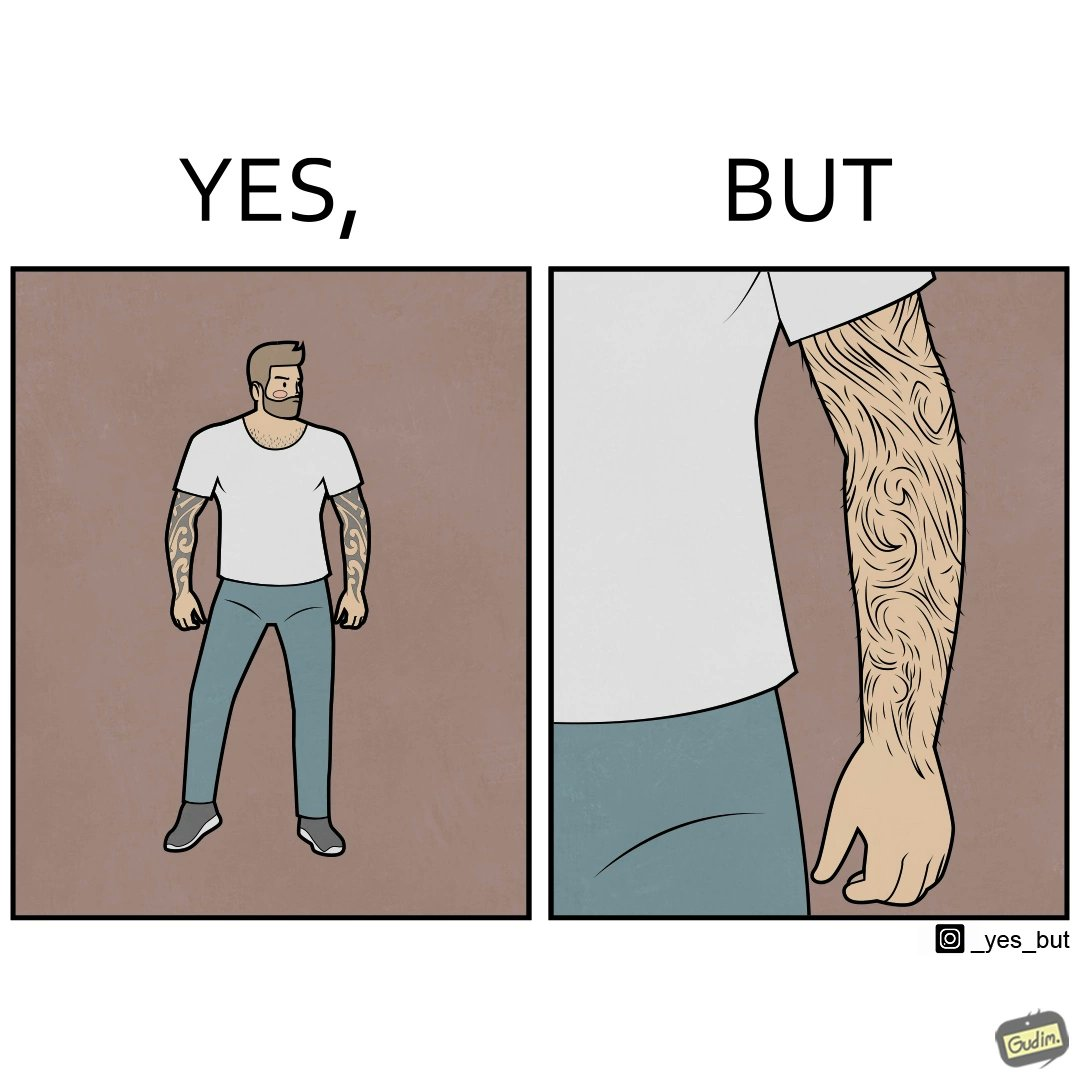What is the satirical meaning behind this image? The image is funny because while from the distance it seems that the man has big tattoos on both of his arms upon a closer look at the arms it turns out there is no tattoo and what seemed to be tattoos are just hairs on his arm. 